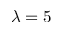<formula> <loc_0><loc_0><loc_500><loc_500>\lambda = 5</formula> 